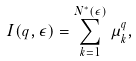Convert formula to latex. <formula><loc_0><loc_0><loc_500><loc_500>I ( q , \epsilon ) = \sum _ { k = 1 } ^ { N ^ { * } ( \epsilon ) } \mu _ { k } ^ { q } ,</formula> 